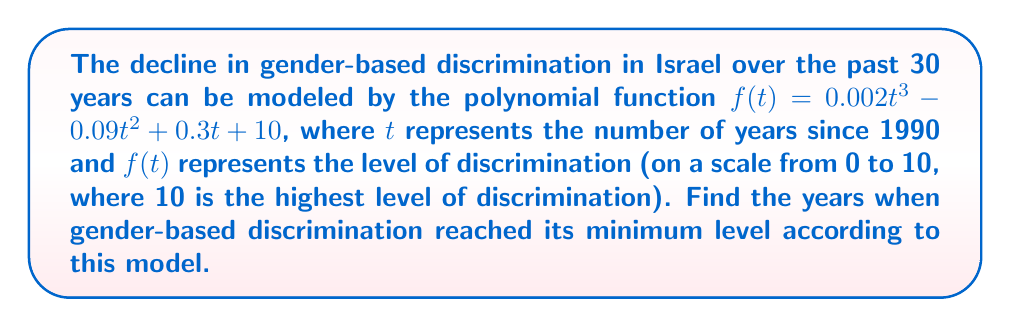Teach me how to tackle this problem. To find the years when gender-based discrimination reached its minimum level, we need to find the roots of the derivative of $f(t)$.

1) First, let's find the derivative of $f(t)$:
   $$f'(t) = 0.006t^2 - 0.18t + 0.3$$

2) To find the minimum points, we set $f'(t) = 0$:
   $$0.006t^2 - 0.18t + 0.3 = 0$$

3) This is a quadratic equation. We can solve it using the quadratic formula:
   $$t = \frac{-b \pm \sqrt{b^2 - 4ac}}{2a}$$
   where $a = 0.006$, $b = -0.18$, and $c = 0.3$

4) Substituting these values:
   $$t = \frac{0.18 \pm \sqrt{(-0.18)^2 - 4(0.006)(0.3)}}{2(0.006)}$$

5) Simplifying:
   $$t = \frac{0.18 \pm \sqrt{0.0324 - 0.0072}}{0.012} = \frac{0.18 \pm \sqrt{0.0252}}{0.012} = \frac{0.18 \pm 0.1587}{0.012}$$

6) This gives us two solutions:
   $$t_1 = \frac{0.18 + 0.1587}{0.012} \approx 28.23$$
   $$t_2 = \frac{0.18 - 0.1587}{0.012} \approx 1.77$$

7) Since $t$ represents years since 1990, we add 1990 to these values:
   1990 + 28.23 ≈ 2018.23
   1990 + 1.77 ≈ 1991.77

Therefore, according to this model, gender-based discrimination reached its minimum levels in approximately 1992 and 2018.
Answer: 1992 and 2018 